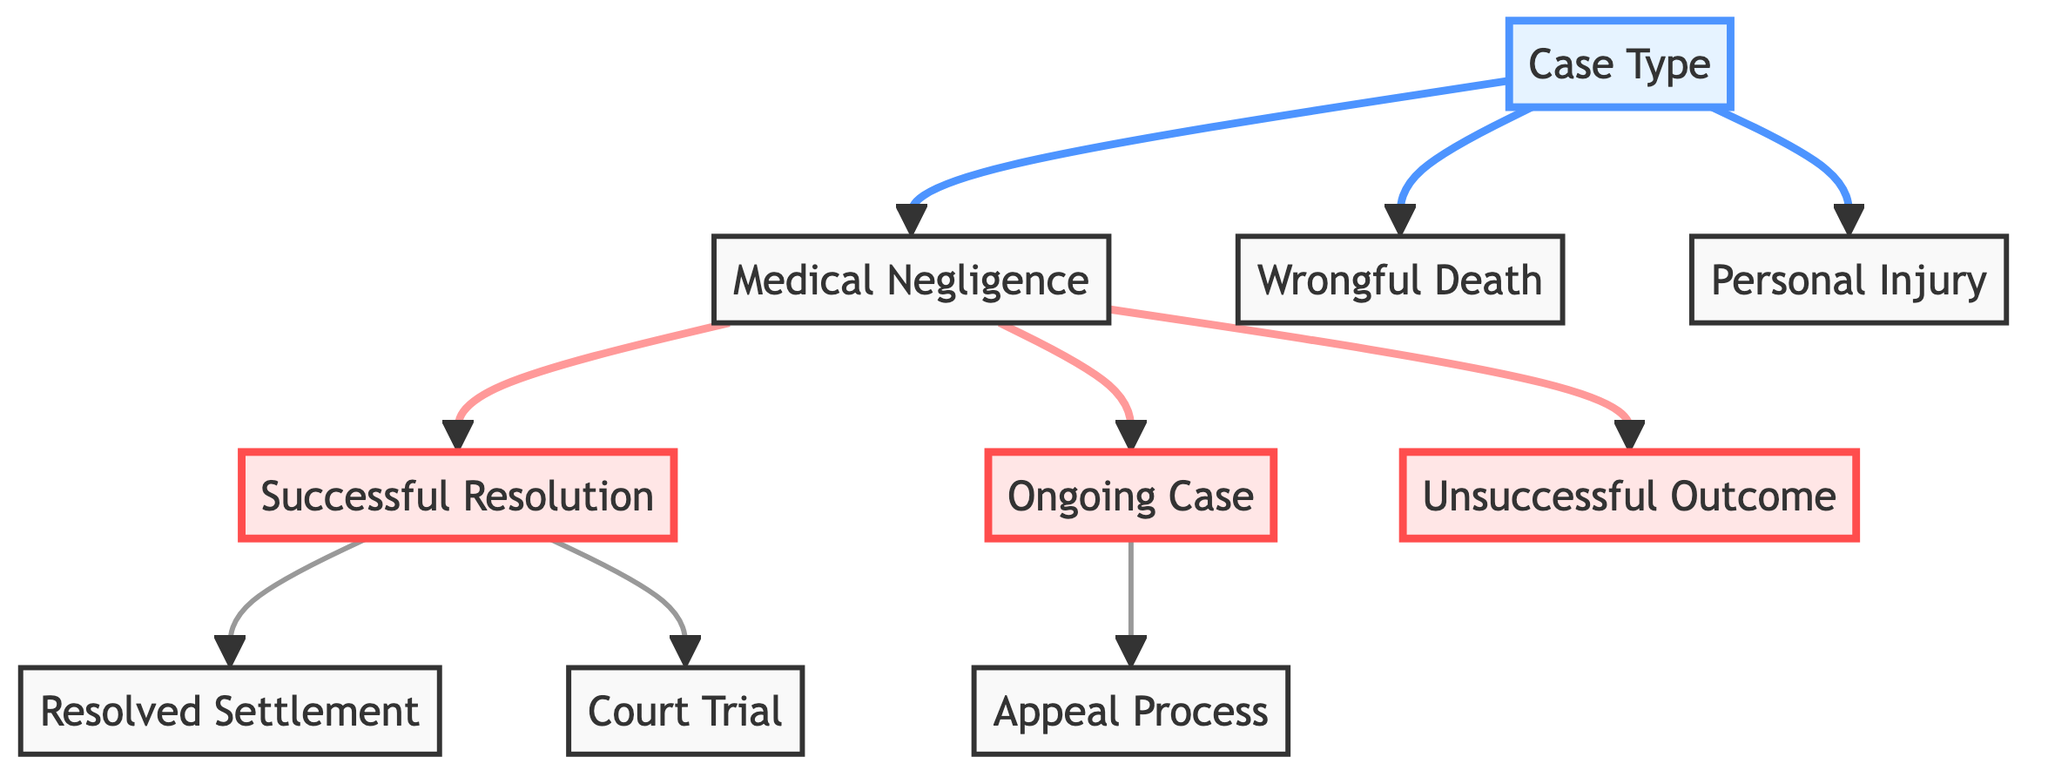What are the types of cases represented in the diagram? The diagram includes nodes representing three types of cases: Medical Negligence, Wrongful Death, and Personal Injury. These can be found directly connected to the "Case Type" node.
Answer: Medical Negligence, Wrongful Death, Personal Injury How many outcomes are there for Medical Negligence cases? From the Medical Negligence node, three different outcomes can be observed: Successful Resolution, Ongoing Case, and Unsuccessful Outcome, indicating a total of three outcomes.
Answer: 3 What is the next step after a Successful Resolution? The Successful Resolution node has two outgoing connections: one leading to Resolved Settlement and another to Court Trial, indicating that either outcome can follow a Successful Resolution.
Answer: Resolved Settlement or Court Trial What happens to an Ongoing Case? The diagram shows that if a case is ongoing, the next step is the Appeal Process, which is the only outcome for the Ongoing Case node, leading to further legal proceedings.
Answer: Appeal Process What connects Medical Negligence and Ongoing Case? The diagram indicates a direct edge from the Medical Negligence node to the Ongoing Case node, suggesting that Ongoing Cases can arise from Medical Negligence cases specifically.
Answer: Medical Negligence What type of trial might result from a Successful Resolution? Following the Successful Resolution, the pathway in the diagram shows a possible outcome leading to the Court Trial, indicating that a trial may occur after a resolution is deemed successful.
Answer: Court Trial How many nodes in total are there in the diagram? Counting all the nodes listed, which include the Case Type and the outcomes (successful, ongoing, unsuccessful), there are ten distinct nodes representing this information in the directed graph.
Answer: 10 What does an Unsuccessful Outcome signify? The Unsuccessful Outcome node indicates a negative resolution to a case that starts from Medical Negligence, suggesting that the legal assistance did not yield the desired results for that case.
Answer: Unsuccessful Outcome What is the structure of the flow starting from the Case Type? Starting from the Case Type node, the structure leads to three types of cases; from Medical Negligence, it can further lead to three outcomes, showing multiple paths based on the initial case type chosen.
Answer: Divergent paths to different case outcomes 